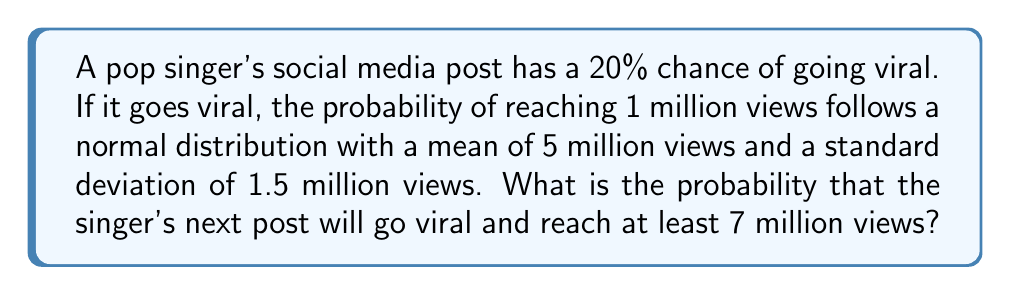Provide a solution to this math problem. Let's approach this step-by-step:

1) First, we need to calculate two probabilities:
   a) The probability of the post going viral (P(V))
   b) The probability of reaching at least 7 million views, given that it goes viral (P(R|V))

2) P(V) is given as 20% or 0.2

3) For P(R|V), we need to use the normal distribution:
   - Mean (μ) = 5 million
   - Standard deviation (σ) = 1.5 million
   - We want P(X ≥ 7 million)

4) To calculate this, we need to standardize the normal distribution:
   $$ Z = \frac{X - μ}{σ} = \frac{7 - 5}{1.5} = \frac{2}{1.5} ≈ 1.33 $$

5) Now we need to find P(Z ≥ 1.33) using a standard normal table or calculator.
   P(Z ≥ 1.33) ≈ 0.0918

6) So, P(R|V) ≈ 0.0918

7) The probability we're looking for is the product of these two probabilities:
   $$ P(\text{viral and ≥7M views}) = P(V) × P(R|V) $$
   $$ = 0.2 × 0.0918 ≈ 0.01836 $$

8) Convert to a percentage: 0.01836 × 100% ≈ 1.84%
Answer: 1.84% 